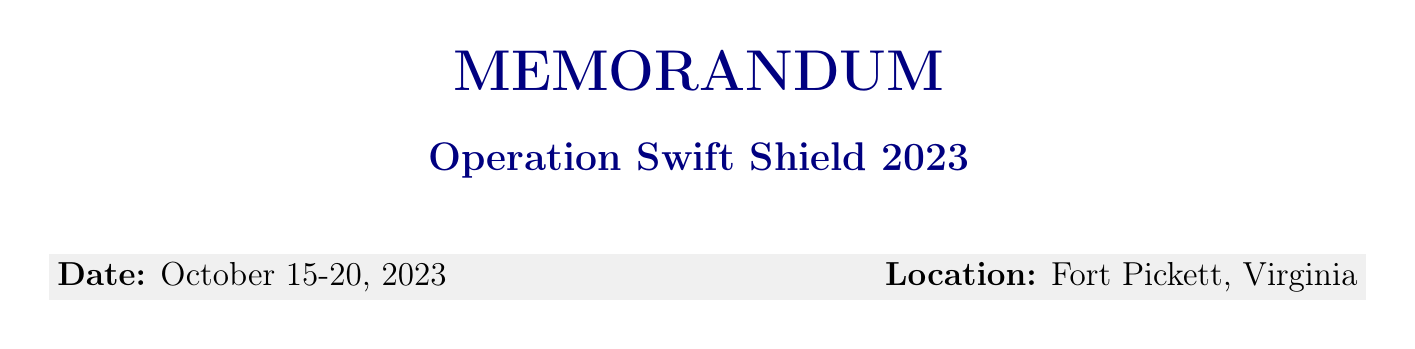What is the name of the exercise? The name of the exercise is explicitly stated in the document.
Answer: Operation Swift Shield 2023 What are the dates of the exercise? The date range for the exercise is specified in the document.
Answer: October 15-20, 2023 Who is the lead coordinating agency? The document identifies the Department of Homeland Security as the lead agency.
Answer: Department of Homeland Security (DHS) What scenario is being practiced during the exercise? The document provides the scenario as part of the exercise overview.
Answer: Category 4 hurricane making landfall on the East Coast How many field hospitals are required? The document lists the medical logistical requirements, including the number of field hospitals.
Answer: 2 field hospitals What is the total budget allocation for the exercise? The budget allocation is clearly mentioned in the budget section of the document.
Answer: $5.2 million What is one of the expected outcomes of the exercise? The document details expected outcomes, which summarize the goals of the exercise.
Answer: Improved interagency coordination protocols What will happen after the exercise? The document outlines post-exercise activities that will take place after the exercise.
Answer: After-action review meeting What is the role of the Department of Defense? The document specifies the role of each participating department.
Answer: Military support and logistics 